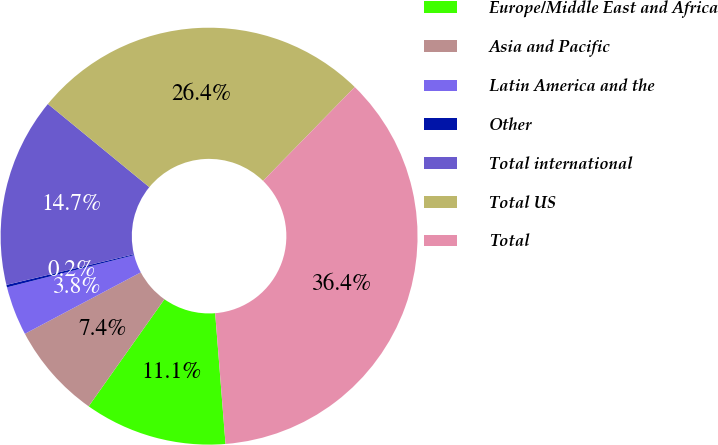Convert chart to OTSL. <chart><loc_0><loc_0><loc_500><loc_500><pie_chart><fcel>Europe/Middle East and Africa<fcel>Asia and Pacific<fcel>Latin America and the<fcel>Other<fcel>Total international<fcel>Total US<fcel>Total<nl><fcel>11.06%<fcel>7.44%<fcel>3.81%<fcel>0.19%<fcel>14.69%<fcel>26.38%<fcel>36.43%<nl></chart> 